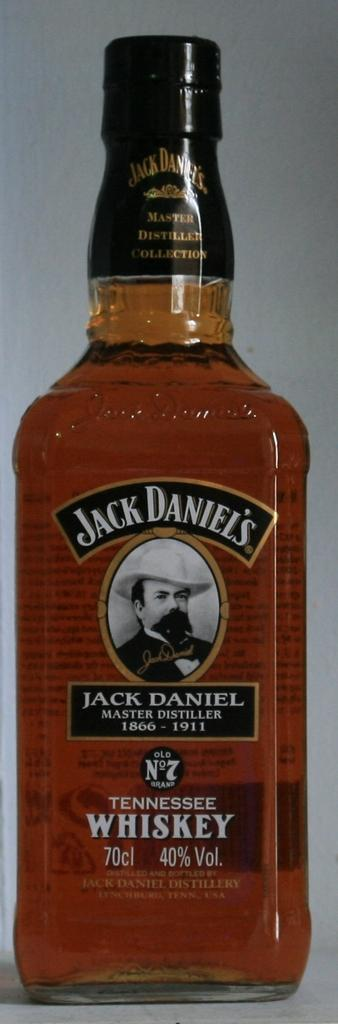What type of alcoholic beverage is in the bottle in the image? There is a bottle of whiskey in the image. What can be seen on the bottle besides the whiskey? The bottle has a photo of a man on it, and the name "Jack Daniel" is printed on the bottle. What title is associated with the bottle? The title "master distiller" is associated with the bottle. Where is the whiskey from? The whiskey is from Tennessee. What type of hat is the man wearing in the image? There is no man wearing a hat in the image; the image only shows a bottle of whiskey with a photo of a man on it. 